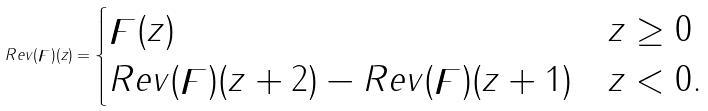<formula> <loc_0><loc_0><loc_500><loc_500>R e v ( \digamma ) ( z ) = \begin{cases} \digamma ( z ) & z \geq 0 \\ R e v ( \digamma ) ( z + 2 ) - R e v ( \digamma ) ( z + 1 ) & z < 0 . \end{cases}</formula> 